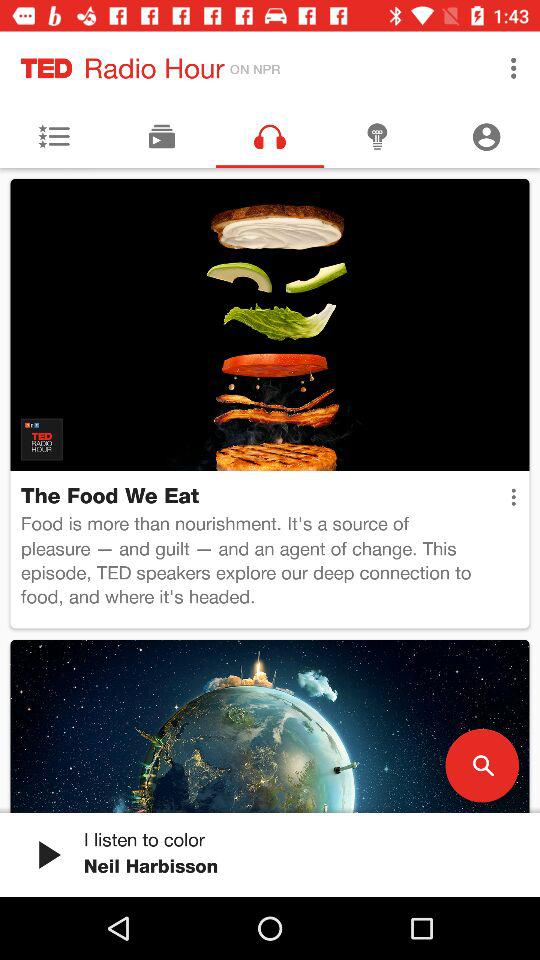What audio was last played? The last played audio was "I listen to color". 